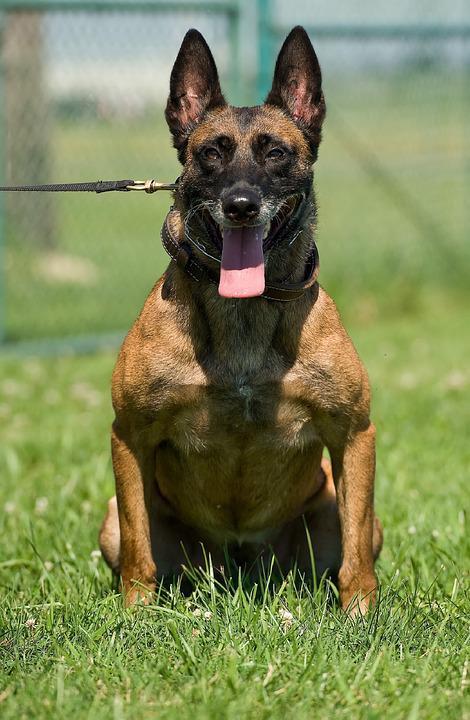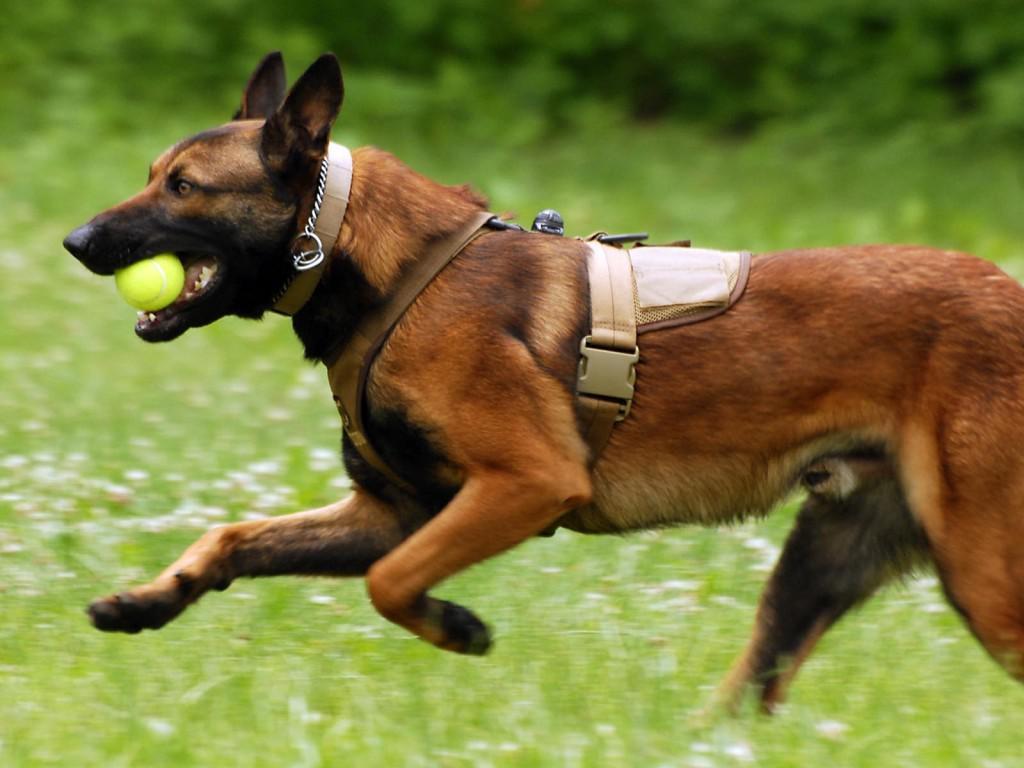The first image is the image on the left, the second image is the image on the right. Examine the images to the left and right. Is the description "At least one animal has no visible collar or leash." accurate? Answer yes or no. No. 